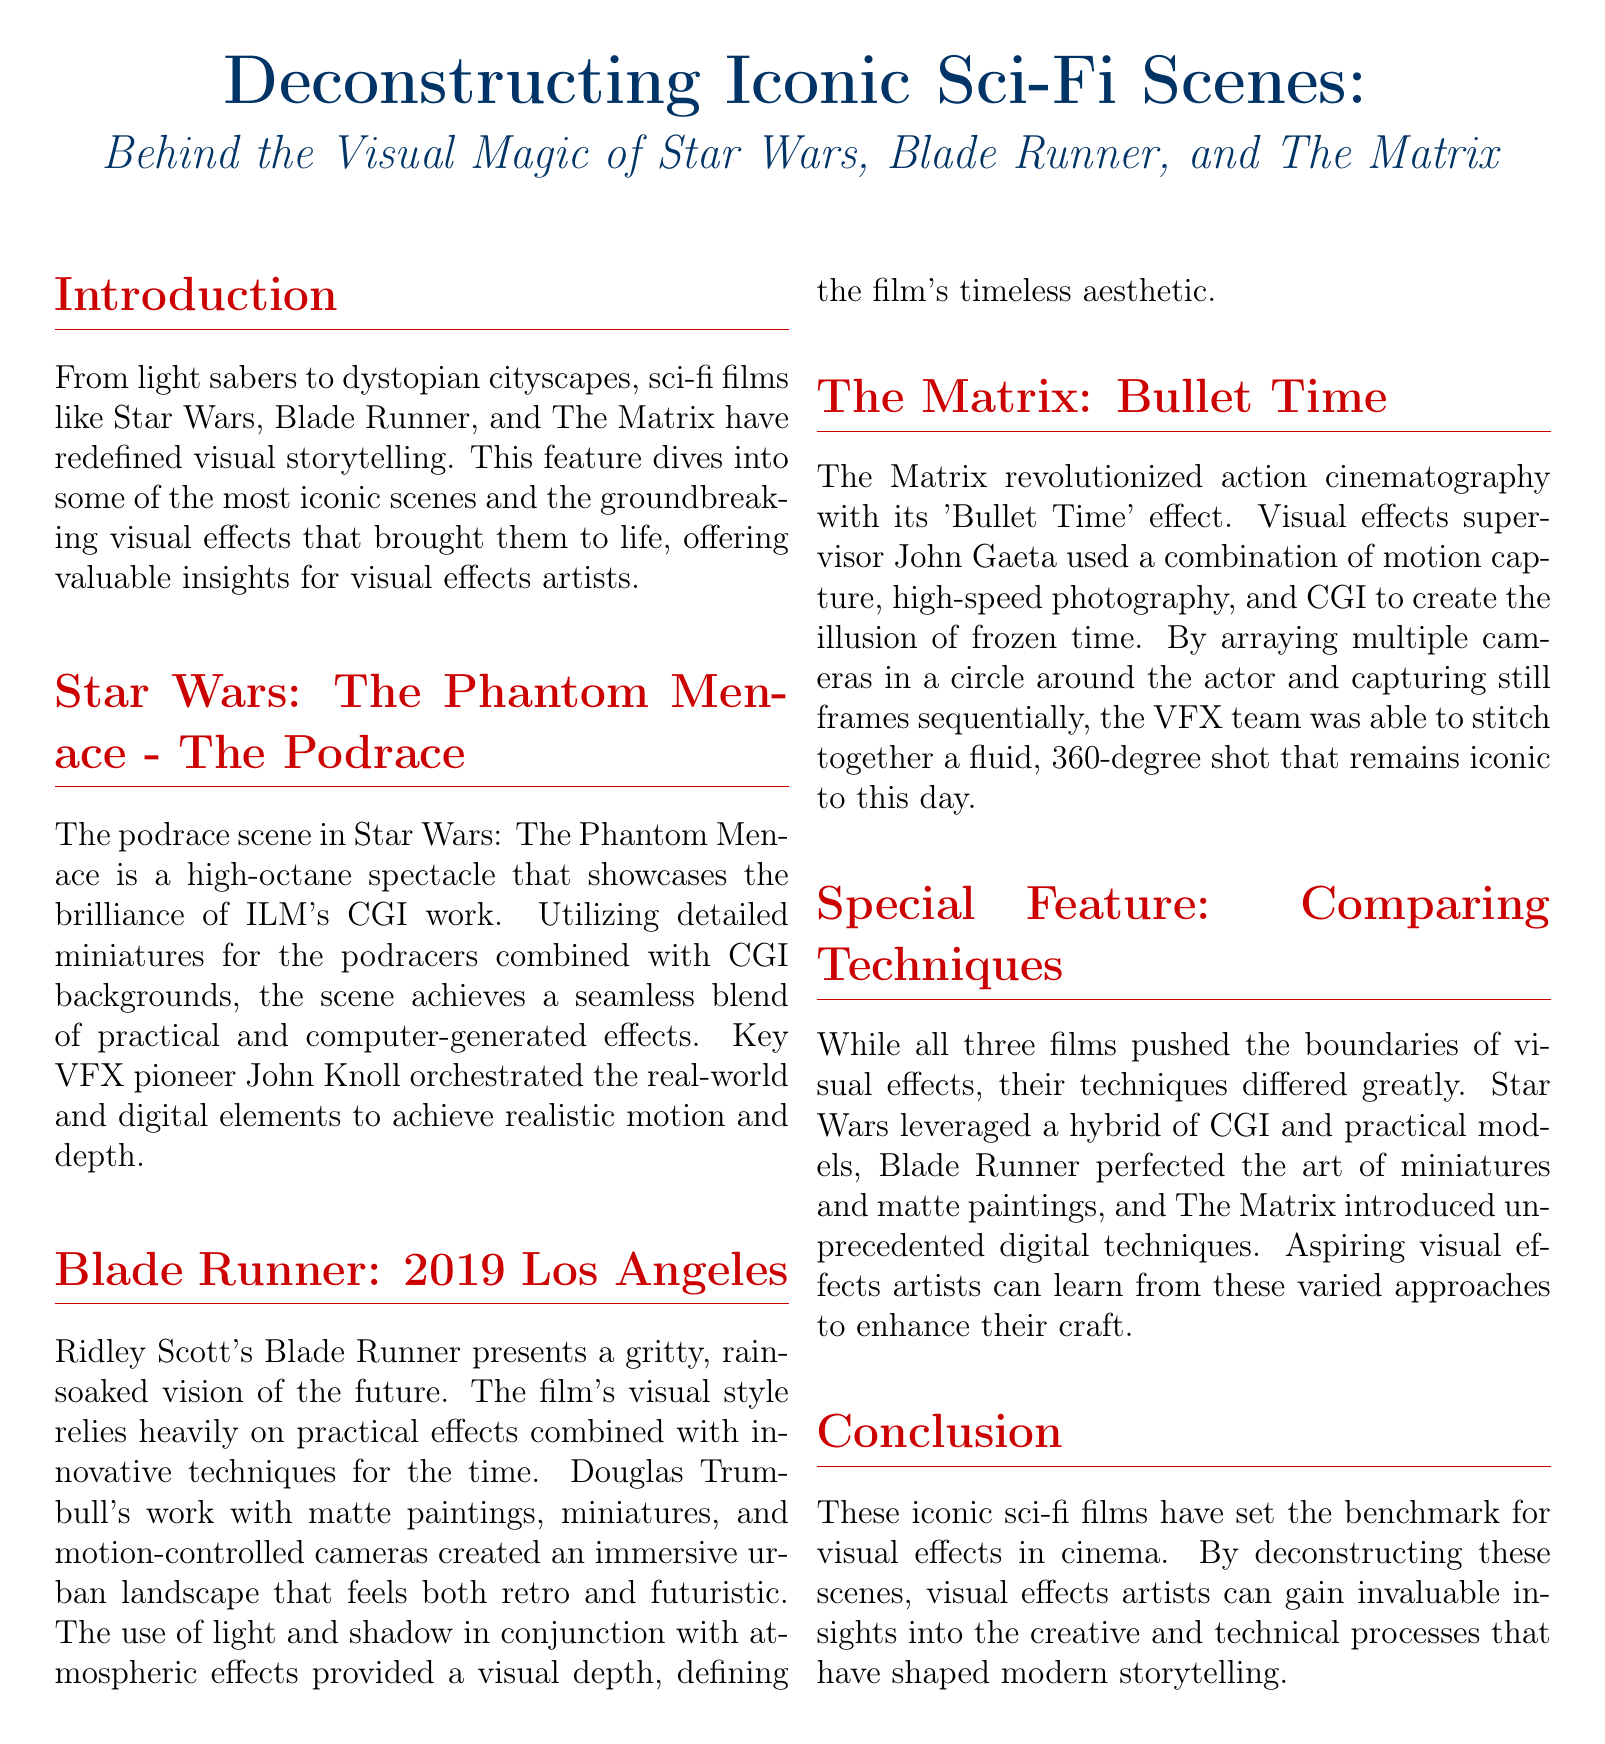What iconic scene is highlighted from Star Wars? The document mentions the podrace scene as an iconic moment in Star Wars: The Phantom Menace.
Answer: podrace Who was the visual effects pioneer for the podrace scene? The document identifies key VFX pioneer John Knoll as the orchestrator of the podrace scene's effects.
Answer: John Knoll What technique did The Matrix introduce? The text states that The Matrix introduced the 'Bullet Time' effect as a revolutionary technique in cinematography.
Answer: Bullet Time Which film used matte paintings to create its visual style? The document attributes the use of matte paintings to Blade Runner in its visual storytelling.
Answer: Blade Runner What major visual effect technique did Douglas Trumbull work with in Blade Runner? The document mentions that Douglas Trumbull worked with miniatures and motion-controlled cameras in Blade Runner.
Answer: miniatures What color is used for the title in the document? The title color used in the document is described as RGB 0,51,102.
Answer: RGB 0,51,102 How many films are analyzed in the document? The document specifically mentions three films: Star Wars, Blade Runner, and The Matrix.
Answer: three What is the conclusion of the document regarding iconic sci-fi films? The conclusion states that these films have set benchmarks for visual effects in cinema.
Answer: benchmarks 